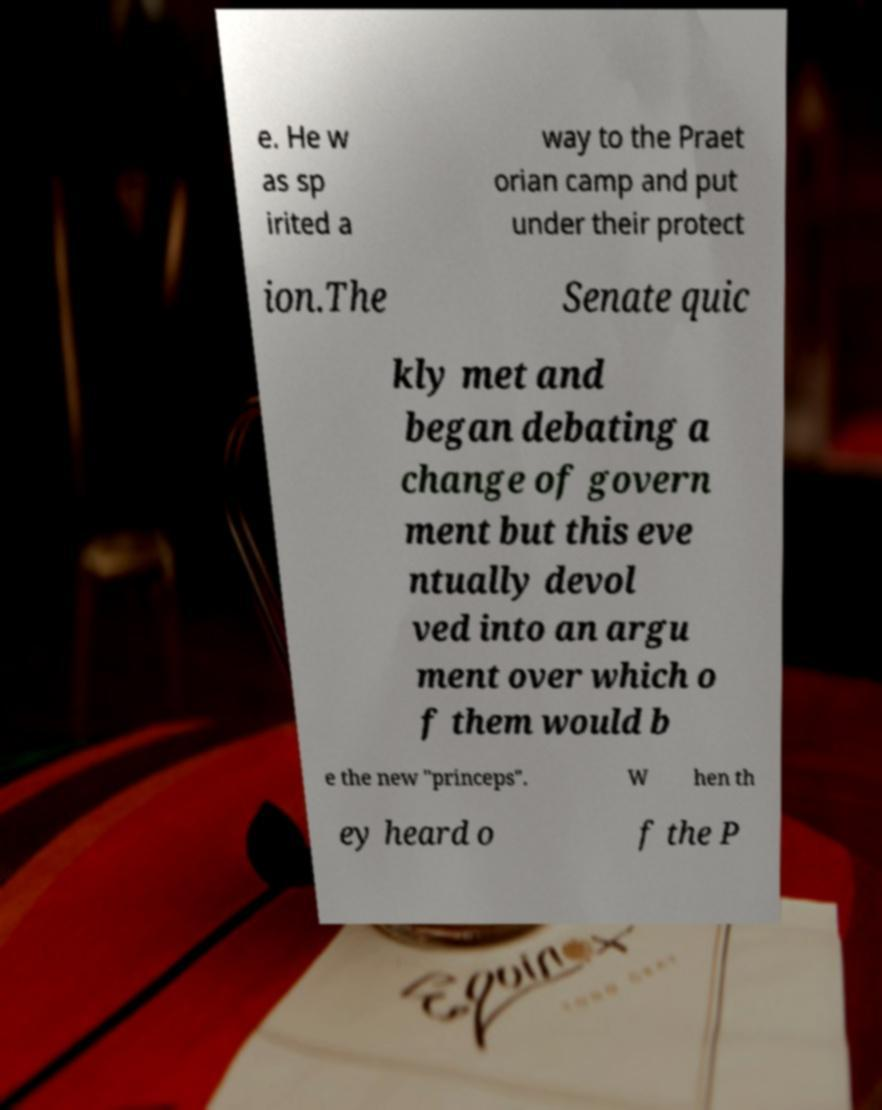Can you accurately transcribe the text from the provided image for me? e. He w as sp irited a way to the Praet orian camp and put under their protect ion.The Senate quic kly met and began debating a change of govern ment but this eve ntually devol ved into an argu ment over which o f them would b e the new "princeps". W hen th ey heard o f the P 